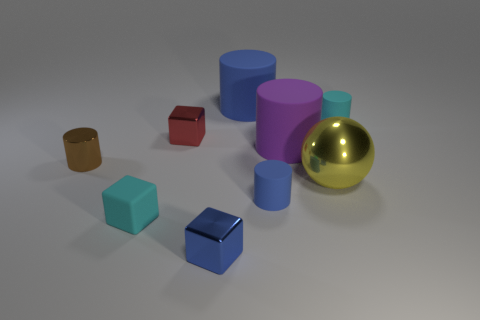Subtract all big purple cylinders. How many cylinders are left? 4 Subtract 2 cubes. How many cubes are left? 1 Subtract all cyan cylinders. How many cylinders are left? 4 Subtract 0 brown balls. How many objects are left? 9 Subtract all spheres. How many objects are left? 8 Subtract all brown cylinders. Subtract all cyan blocks. How many cylinders are left? 4 Subtract all blue blocks. How many red spheres are left? 0 Subtract all tiny rubber cylinders. Subtract all small brown metallic spheres. How many objects are left? 7 Add 5 brown shiny objects. How many brown shiny objects are left? 6 Add 6 small blue blocks. How many small blue blocks exist? 7 